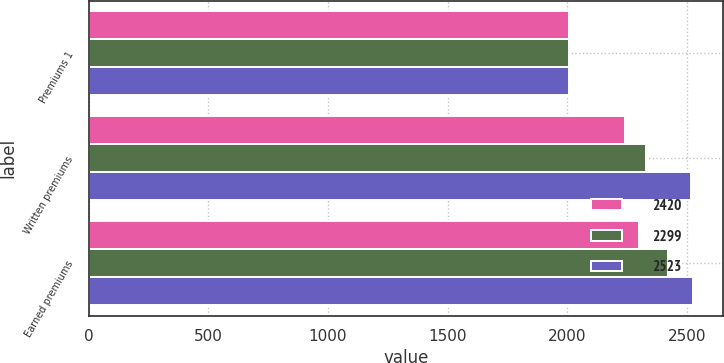Convert chart to OTSL. <chart><loc_0><loc_0><loc_500><loc_500><stacked_bar_chart><ecel><fcel>Premiums 1<fcel>Written premiums<fcel>Earned premiums<nl><fcel>2420<fcel>2008<fcel>2242<fcel>2299<nl><fcel>2299<fcel>2007<fcel>2326<fcel>2420<nl><fcel>2523<fcel>2006<fcel>2515<fcel>2523<nl></chart> 